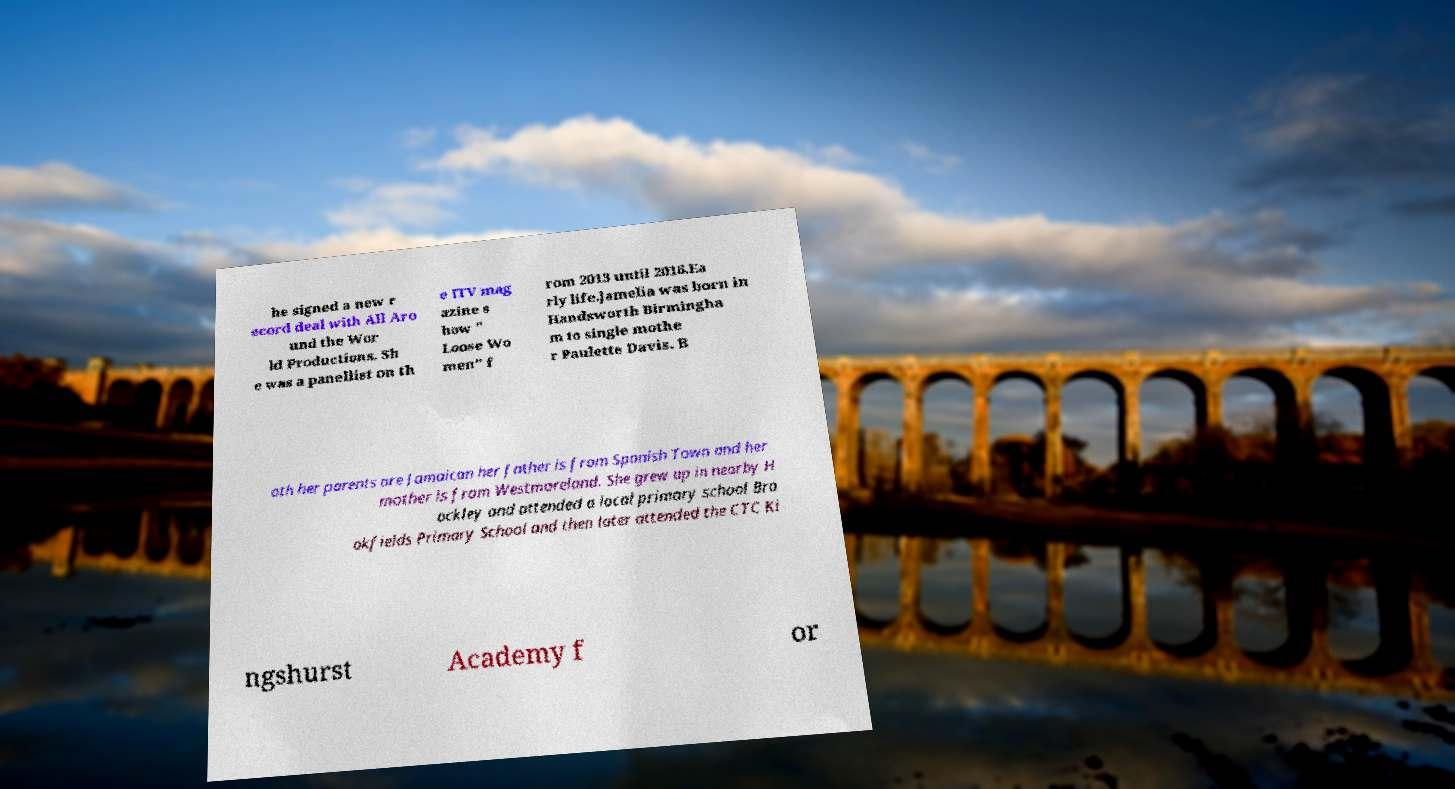Can you read and provide the text displayed in the image?This photo seems to have some interesting text. Can you extract and type it out for me? he signed a new r ecord deal with All Aro und the Wor ld Productions. Sh e was a panellist on th e ITV mag azine s how " Loose Wo men" f rom 2013 until 2016.Ea rly life.Jamelia was born in Handsworth Birmingha m to single mothe r Paulette Davis. B oth her parents are Jamaican her father is from Spanish Town and her mother is from Westmoreland. She grew up in nearby H ockley and attended a local primary school Bro okfields Primary School and then later attended the CTC Ki ngshurst Academy f or 